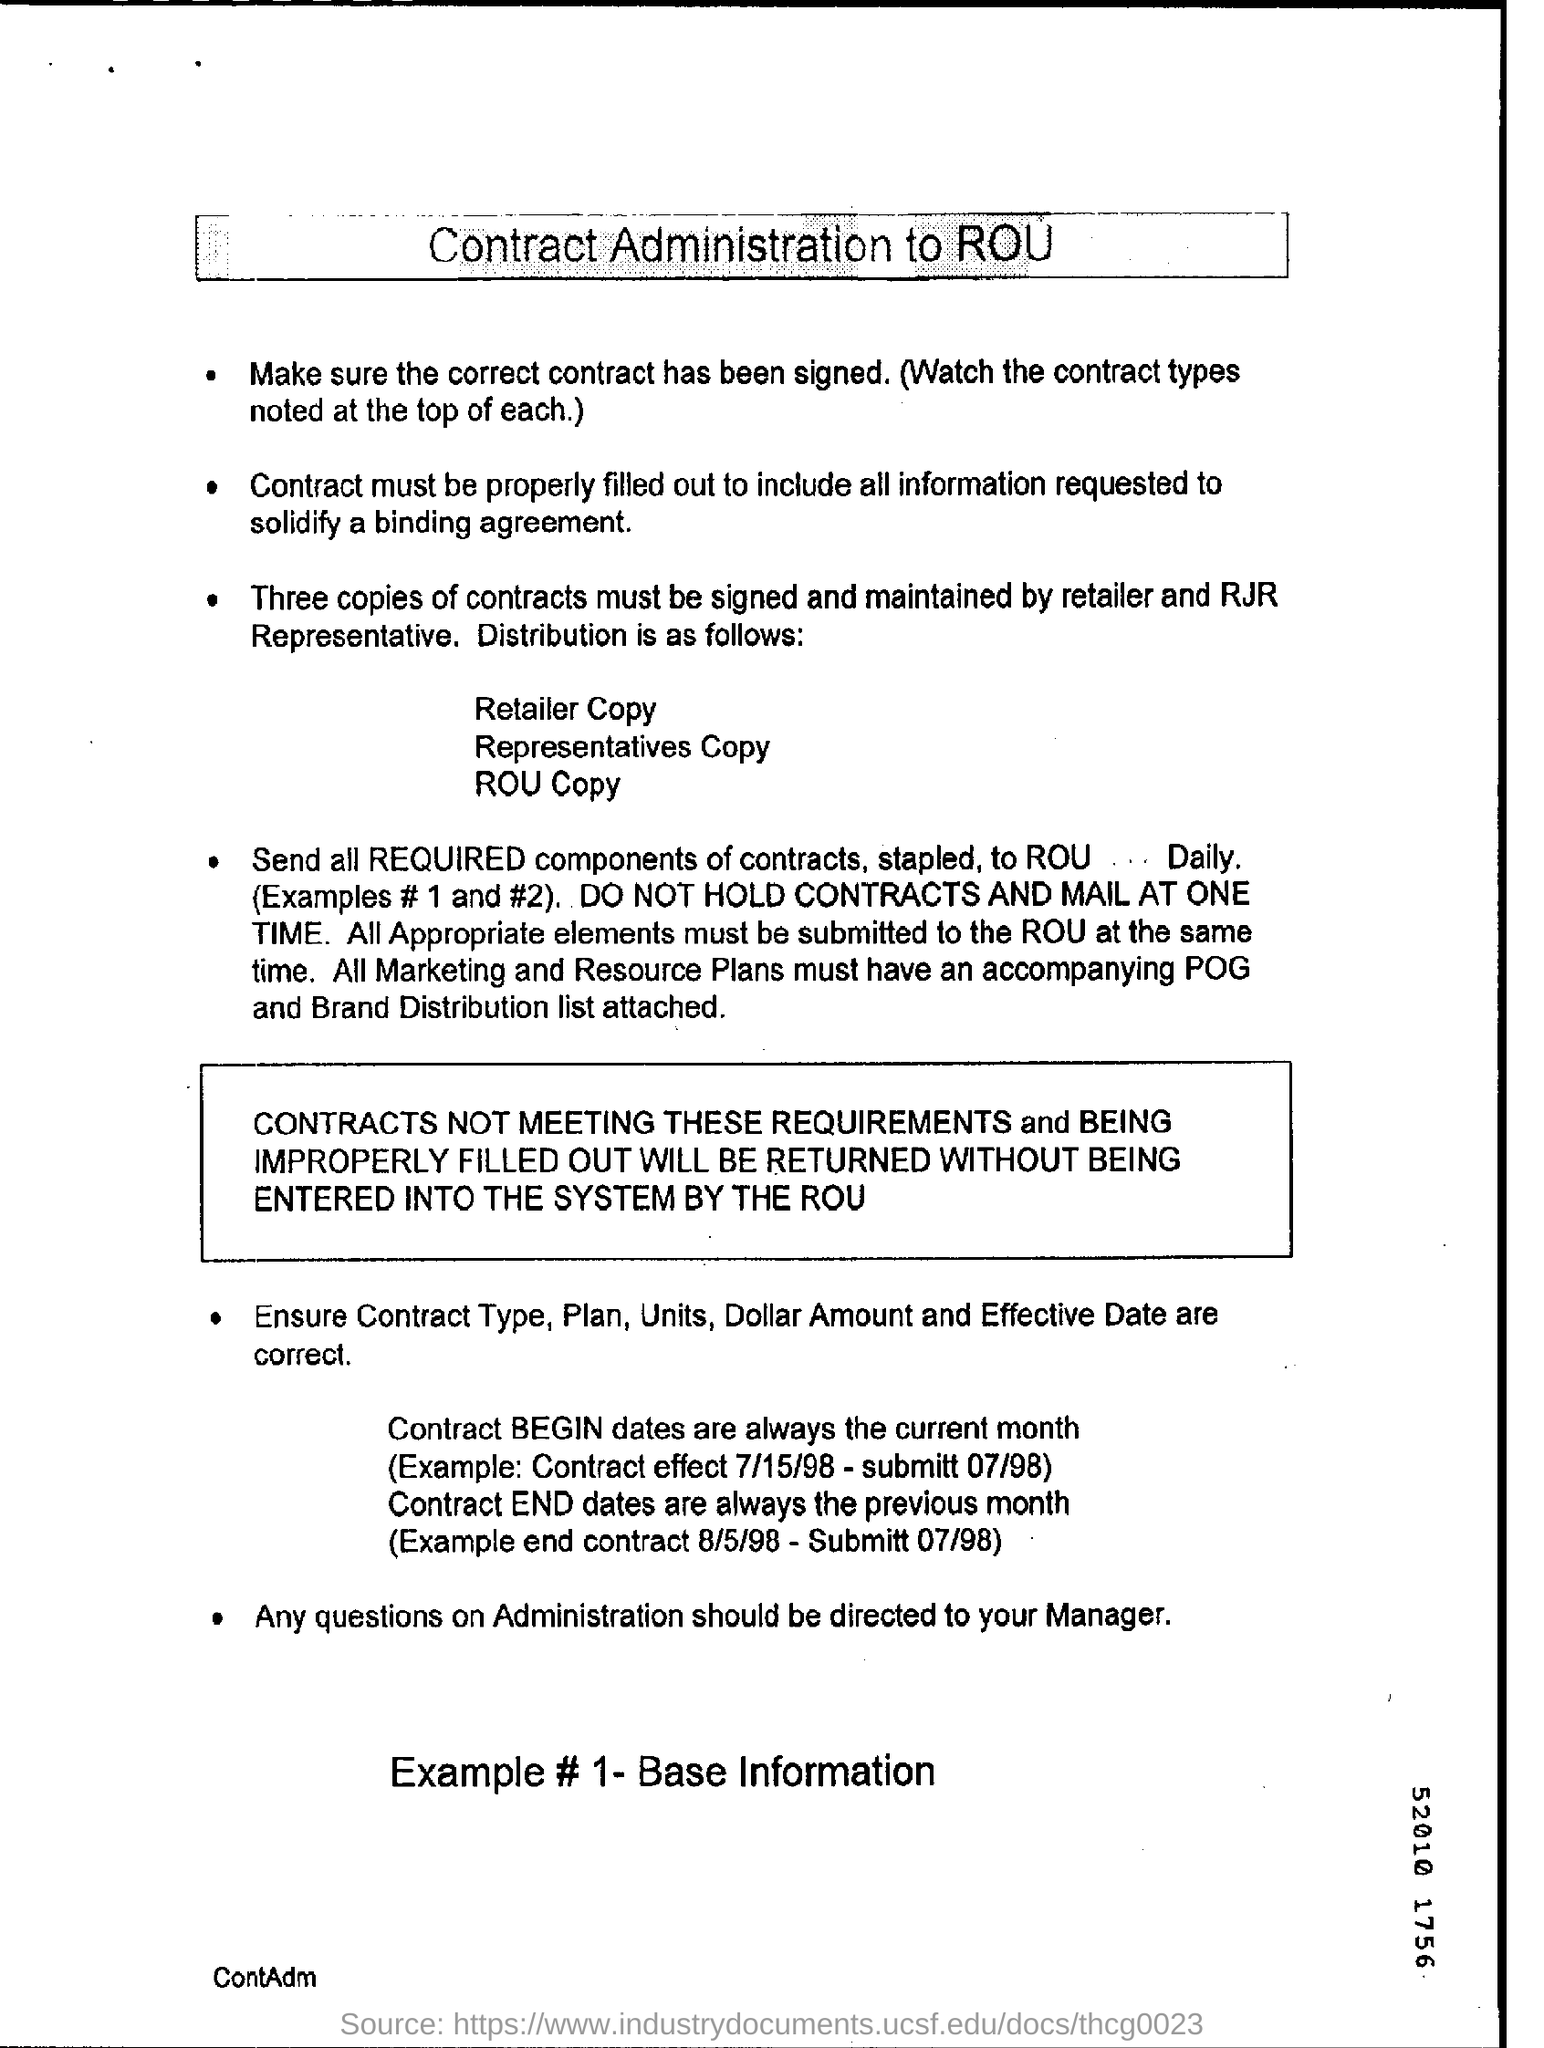Draw attention to some important aspects in this diagram. It is required that the retailer and RJR Representative sign and maintain a minimum of three copies of contracts. The person to whom questions on Administration should be directed is the Manager. What is the current month in the contract, according to the dates provided in the code? 